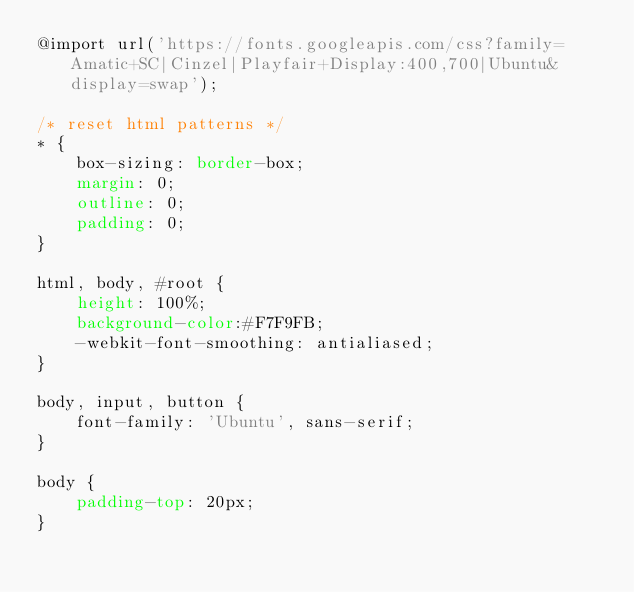Convert code to text. <code><loc_0><loc_0><loc_500><loc_500><_CSS_>@import url('https://fonts.googleapis.com/css?family=Amatic+SC|Cinzel|Playfair+Display:400,700|Ubuntu&display=swap');

/* reset html patterns */
* {
    box-sizing: border-box;
    margin: 0;
    outline: 0;
    padding: 0;
}

html, body, #root {
    height: 100%;
    background-color:#F7F9FB;
    -webkit-font-smoothing: antialiased;
}

body, input, button {
    font-family: 'Ubuntu', sans-serif;
}

body {
    padding-top: 20px;
}</code> 